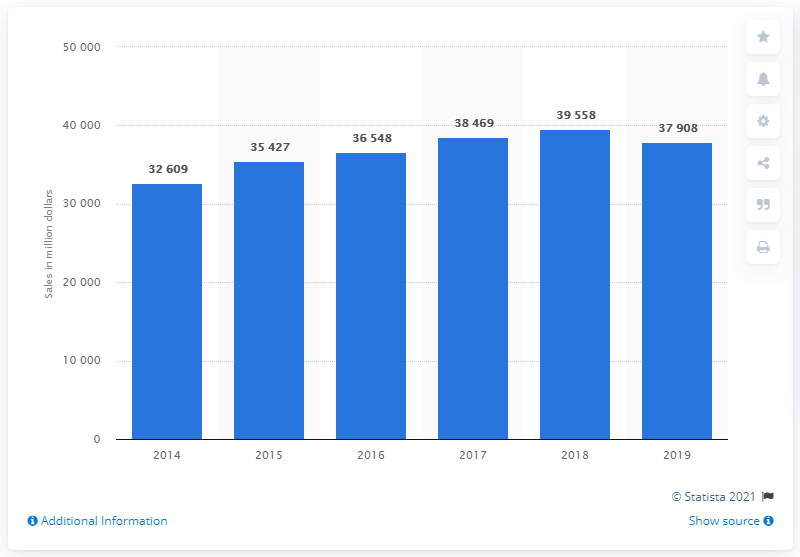Specify some key components in this picture. In the year 2019, the direct selling industry generated approximately 37,908 in revenue. 